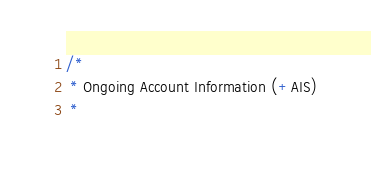Convert code to text. <code><loc_0><loc_0><loc_500><loc_500><_C#_>/* 
 * Ongoing Account Information (+AIS)
 *</code> 